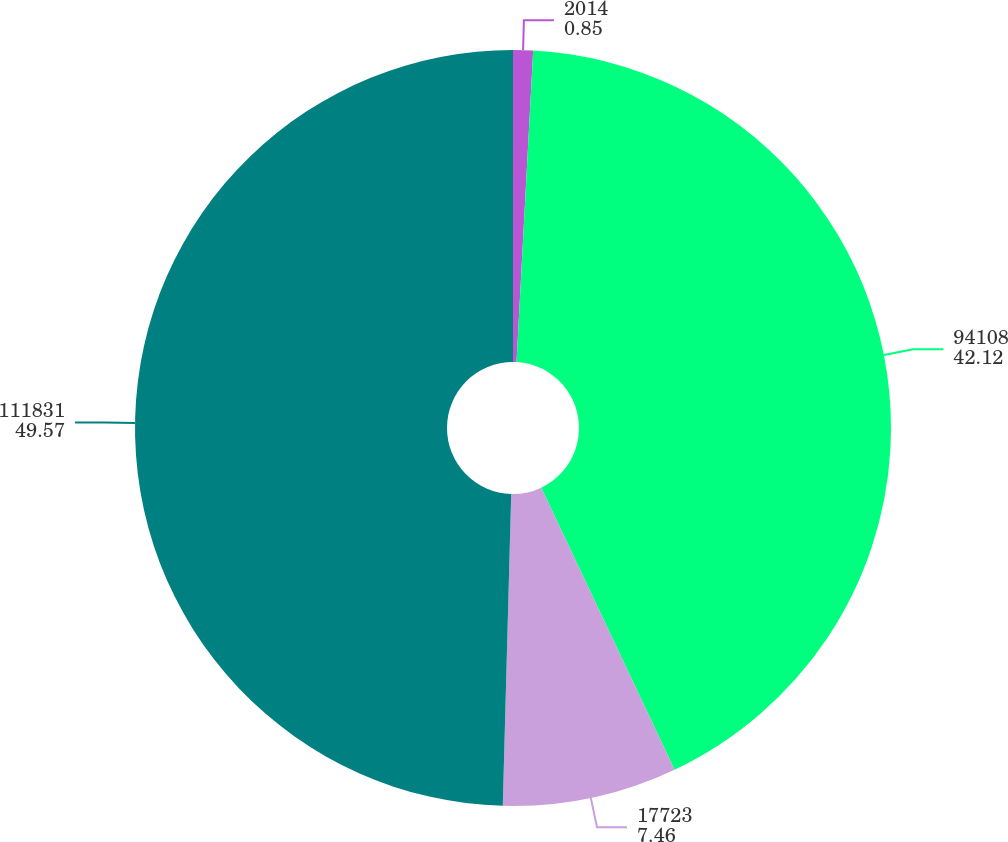Convert chart to OTSL. <chart><loc_0><loc_0><loc_500><loc_500><pie_chart><fcel>2014<fcel>94108<fcel>17723<fcel>111831<nl><fcel>0.85%<fcel>42.12%<fcel>7.46%<fcel>49.57%<nl></chart> 